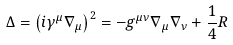Convert formula to latex. <formula><loc_0><loc_0><loc_500><loc_500>\Delta = \left ( i \gamma ^ { \mu } \nabla _ { \mu } \right ) ^ { 2 } = - g ^ { \mu \nu } \nabla _ { \mu } \nabla _ { \nu } + \frac { 1 } { 4 } R</formula> 